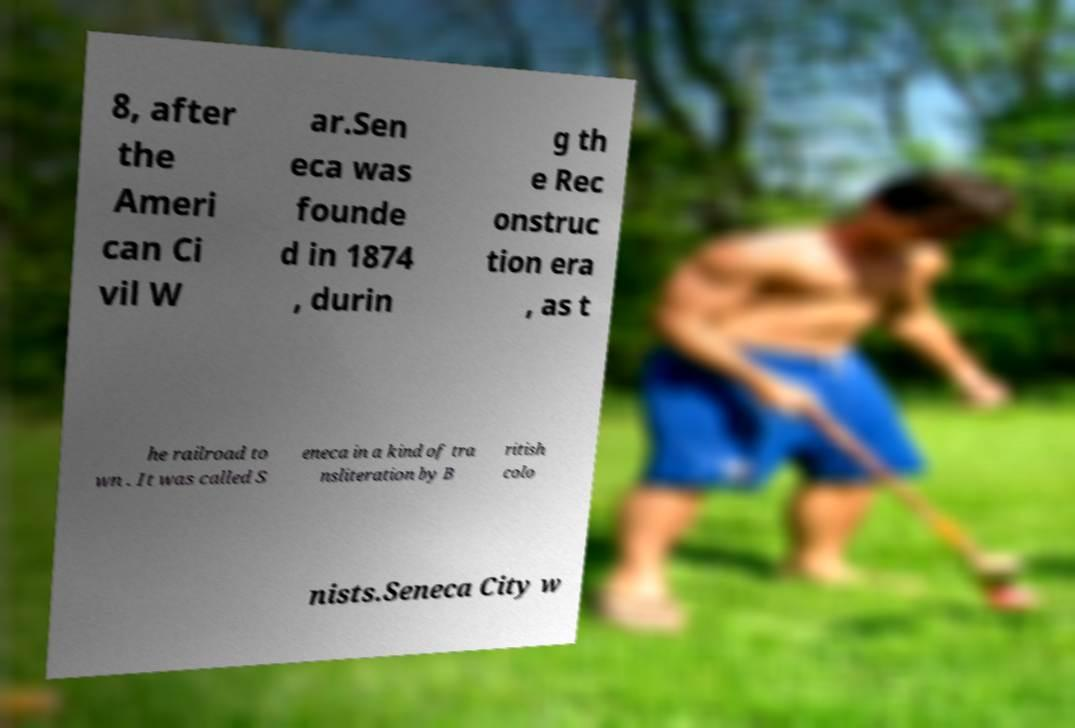Could you assist in decoding the text presented in this image and type it out clearly? 8, after the Ameri can Ci vil W ar.Sen eca was founde d in 1874 , durin g th e Rec onstruc tion era , as t he railroad to wn . It was called S eneca in a kind of tra nsliteration by B ritish colo nists.Seneca City w 